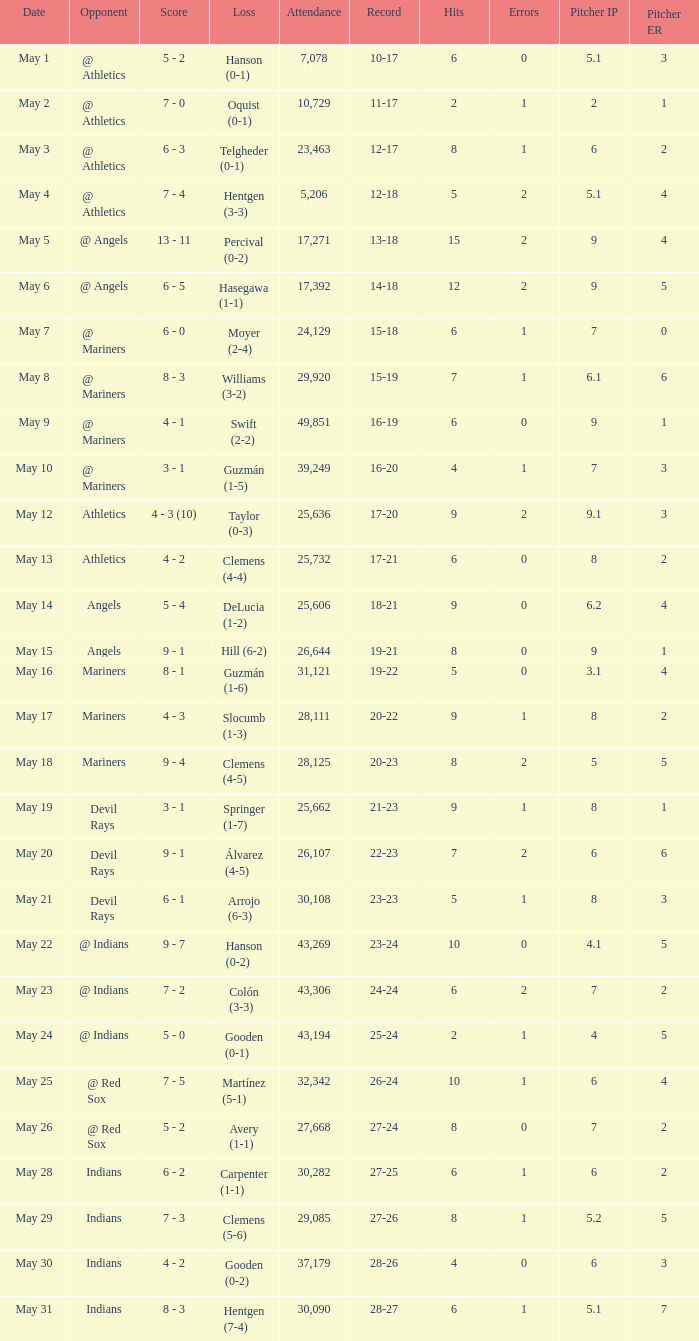For record 25-24, what is the sum of attendance? 1.0. Help me parse the entirety of this table. {'header': ['Date', 'Opponent', 'Score', 'Loss', 'Attendance', 'Record', 'Hits', 'Errors', 'Pitcher IP', 'Pitcher ER'], 'rows': [['May 1', '@ Athletics', '5 - 2', 'Hanson (0-1)', '7,078', '10-17', '6', '0', '5.1', '3'], ['May 2', '@ Athletics', '7 - 0', 'Oquist (0-1)', '10,729', '11-17', '2', '1', '2', '1'], ['May 3', '@ Athletics', '6 - 3', 'Telgheder (0-1)', '23,463', '12-17', '8', '1', '6', '2'], ['May 4', '@ Athletics', '7 - 4', 'Hentgen (3-3)', '5,206', '12-18', '5', '2', '5.1', '4'], ['May 5', '@ Angels', '13 - 11', 'Percival (0-2)', '17,271', '13-18', '15', '2', '9', '4'], ['May 6', '@ Angels', '6 - 5', 'Hasegawa (1-1)', '17,392', '14-18', '12', '2', '9', '5'], ['May 7', '@ Mariners', '6 - 0', 'Moyer (2-4)', '24,129', '15-18', '6', '1', '7', '0'], ['May 8', '@ Mariners', '8 - 3', 'Williams (3-2)', '29,920', '15-19', '7', '1', '6.1', '6'], ['May 9', '@ Mariners', '4 - 1', 'Swift (2-2)', '49,851', '16-19', '6', '0', '9', '1'], ['May 10', '@ Mariners', '3 - 1', 'Guzmán (1-5)', '39,249', '16-20', '4', '1', '7', '3'], ['May 12', 'Athletics', '4 - 3 (10)', 'Taylor (0-3)', '25,636', '17-20', '9', '2', '9.1', '3'], ['May 13', 'Athletics', '4 - 2', 'Clemens (4-4)', '25,732', '17-21', '6', '0', '8', '2'], ['May 14', 'Angels', '5 - 4', 'DeLucia (1-2)', '25,606', '18-21', '9', '0', '6.2', '4'], ['May 15', 'Angels', '9 - 1', 'Hill (6-2)', '26,644', '19-21', '8', '0', '9', '1'], ['May 16', 'Mariners', '8 - 1', 'Guzmán (1-6)', '31,121', '19-22', '5', '0', '3.1', '4'], ['May 17', 'Mariners', '4 - 3', 'Slocumb (1-3)', '28,111', '20-22', '9', '1', '8', '2'], ['May 18', 'Mariners', '9 - 4', 'Clemens (4-5)', '28,125', '20-23', '8', '2', '5', '5'], ['May 19', 'Devil Rays', '3 - 1', 'Springer (1-7)', '25,662', '21-23', '9', '1', '8', '1'], ['May 20', 'Devil Rays', '9 - 1', 'Álvarez (4-5)', '26,107', '22-23', '7', '2', '6', '6'], ['May 21', 'Devil Rays', '6 - 1', 'Arrojo (6-3)', '30,108', '23-23', '5', '1', '8', '3'], ['May 22', '@ Indians', '9 - 7', 'Hanson (0-2)', '43,269', '23-24', '10', '0', '4.1', '5'], ['May 23', '@ Indians', '7 - 2', 'Colón (3-3)', '43,306', '24-24', '6', '2', '7', '2'], ['May 24', '@ Indians', '5 - 0', 'Gooden (0-1)', '43,194', '25-24', '2', '1', '4', '5'], ['May 25', '@ Red Sox', '7 - 5', 'Martínez (5-1)', '32,342', '26-24', '10', '1', '6', '4'], ['May 26', '@ Red Sox', '5 - 2', 'Avery (1-1)', '27,668', '27-24', '8', '0', '7', '2'], ['May 28', 'Indians', '6 - 2', 'Carpenter (1-1)', '30,282', '27-25', '6', '1', '6', '2'], ['May 29', 'Indians', '7 - 3', 'Clemens (5-6)', '29,085', '27-26', '8', '1', '5.2', '5'], ['May 30', 'Indians', '4 - 2', 'Gooden (0-2)', '37,179', '28-26', '4', '0', '6', '3'], ['May 31', 'Indians', '8 - 3', 'Hentgen (7-4)', '30,090', '28-27', '6', '1', '5.1', '7']]} 